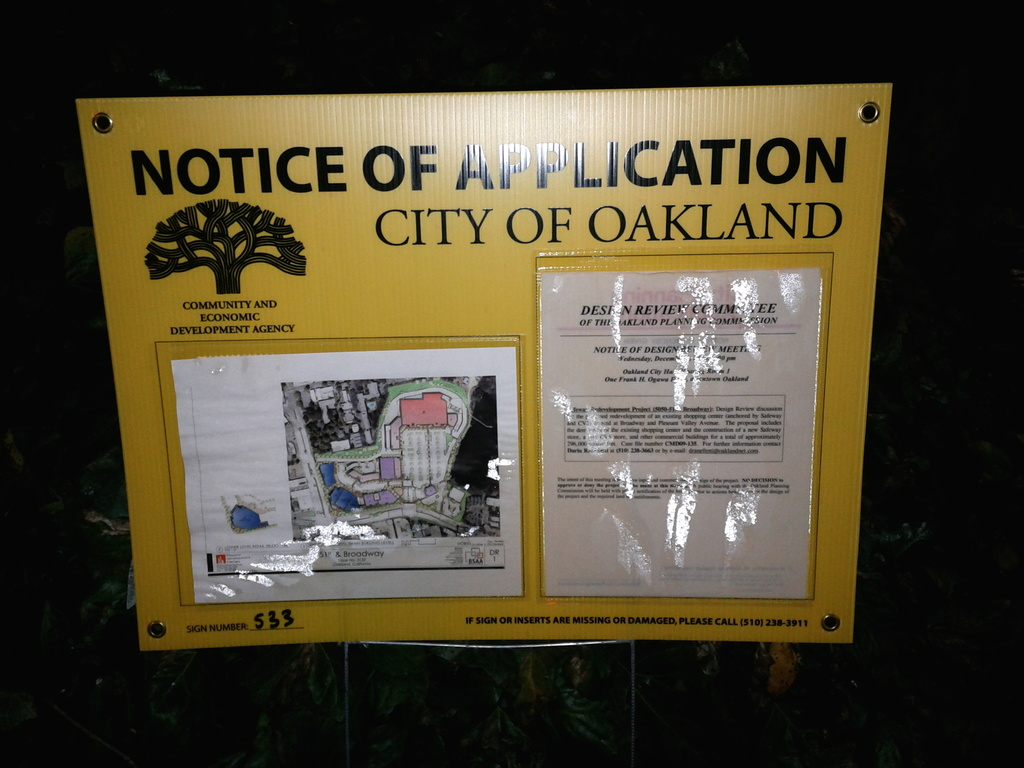What is the significance of the tree symbol on the top of the sign? The tree symbol at the top of the sign represents the City of Oakland’s official logo, which symbolizes strength, resilience, and growth. This emblem reflects the city's commitment to community involvement in its development processes and its hope to thrive through urban projects and initiatives like the one advertised on this sign. 